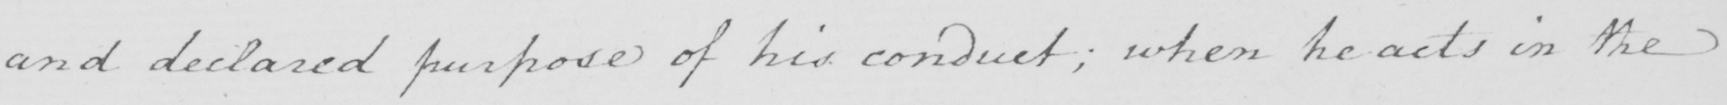Transcribe the text shown in this historical manuscript line. and declared purpose of his conduct  ; when he acts in the 